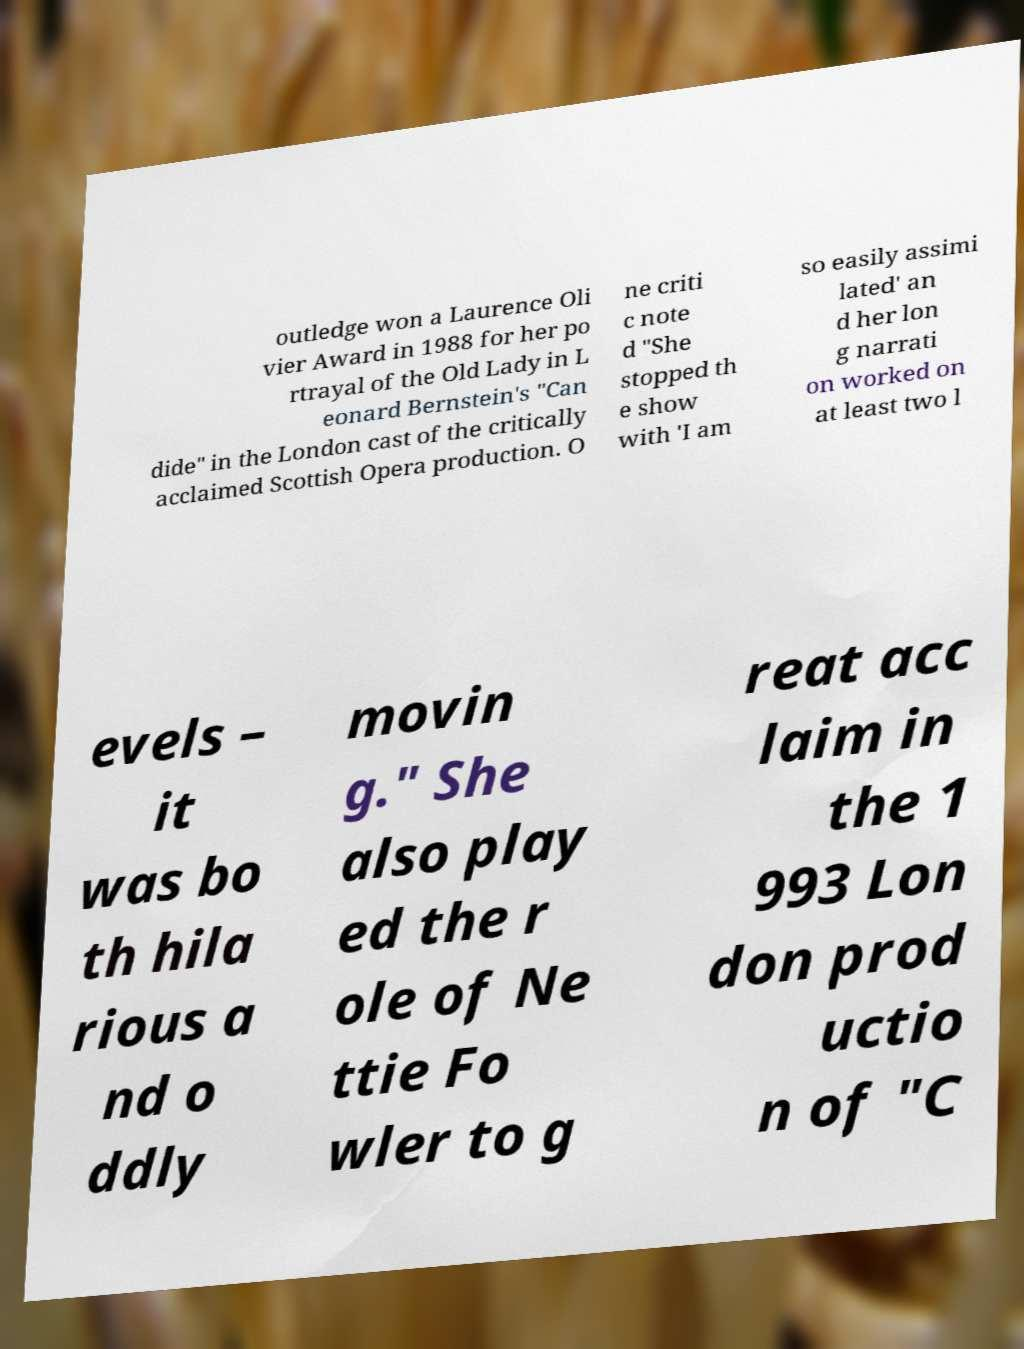Can you read and provide the text displayed in the image?This photo seems to have some interesting text. Can you extract and type it out for me? outledge won a Laurence Oli vier Award in 1988 for her po rtrayal of the Old Lady in L eonard Bernstein's "Can dide" in the London cast of the critically acclaimed Scottish Opera production. O ne criti c note d "She stopped th e show with 'I am so easily assimi lated' an d her lon g narrati on worked on at least two l evels – it was bo th hila rious a nd o ddly movin g." She also play ed the r ole of Ne ttie Fo wler to g reat acc laim in the 1 993 Lon don prod uctio n of "C 